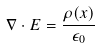<formula> <loc_0><loc_0><loc_500><loc_500>\nabla \cdot E = \frac { \rho ( x ) } { \epsilon _ { 0 } }</formula> 